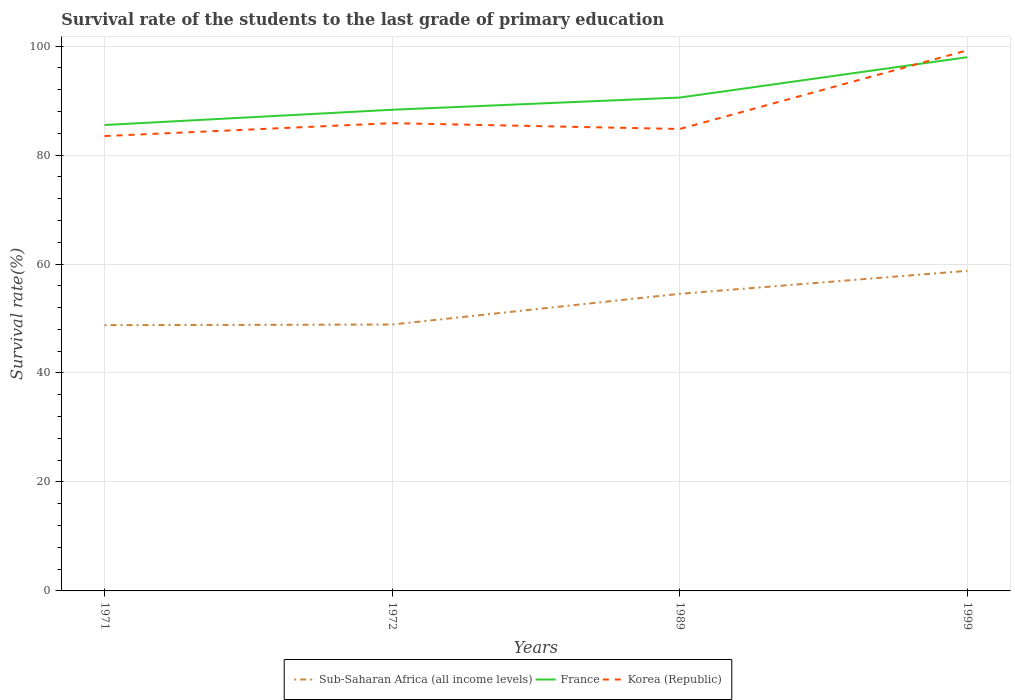How many different coloured lines are there?
Give a very brief answer. 3. Is the number of lines equal to the number of legend labels?
Offer a terse response. Yes. Across all years, what is the maximum survival rate of the students in Korea (Republic)?
Provide a succinct answer. 83.48. In which year was the survival rate of the students in France maximum?
Keep it short and to the point. 1971. What is the total survival rate of the students in Korea (Republic) in the graph?
Offer a very short reply. -15.73. What is the difference between the highest and the second highest survival rate of the students in Korea (Republic)?
Your answer should be very brief. 15.73. Is the survival rate of the students in France strictly greater than the survival rate of the students in Sub-Saharan Africa (all income levels) over the years?
Your answer should be compact. No. How many lines are there?
Your answer should be compact. 3. What is the difference between two consecutive major ticks on the Y-axis?
Give a very brief answer. 20. Are the values on the major ticks of Y-axis written in scientific E-notation?
Make the answer very short. No. Does the graph contain grids?
Offer a terse response. Yes. How many legend labels are there?
Ensure brevity in your answer.  3. How are the legend labels stacked?
Offer a terse response. Horizontal. What is the title of the graph?
Ensure brevity in your answer.  Survival rate of the students to the last grade of primary education. What is the label or title of the X-axis?
Offer a terse response. Years. What is the label or title of the Y-axis?
Your answer should be compact. Survival rate(%). What is the Survival rate(%) in Sub-Saharan Africa (all income levels) in 1971?
Offer a terse response. 48.78. What is the Survival rate(%) in France in 1971?
Make the answer very short. 85.51. What is the Survival rate(%) of Korea (Republic) in 1971?
Make the answer very short. 83.48. What is the Survival rate(%) of Sub-Saharan Africa (all income levels) in 1972?
Give a very brief answer. 48.89. What is the Survival rate(%) in France in 1972?
Make the answer very short. 88.31. What is the Survival rate(%) of Korea (Republic) in 1972?
Offer a terse response. 85.85. What is the Survival rate(%) of Sub-Saharan Africa (all income levels) in 1989?
Keep it short and to the point. 54.53. What is the Survival rate(%) of France in 1989?
Ensure brevity in your answer.  90.55. What is the Survival rate(%) of Korea (Republic) in 1989?
Offer a very short reply. 84.78. What is the Survival rate(%) of Sub-Saharan Africa (all income levels) in 1999?
Make the answer very short. 58.75. What is the Survival rate(%) in France in 1999?
Your response must be concise. 97.96. What is the Survival rate(%) of Korea (Republic) in 1999?
Your response must be concise. 99.22. Across all years, what is the maximum Survival rate(%) of Sub-Saharan Africa (all income levels)?
Offer a terse response. 58.75. Across all years, what is the maximum Survival rate(%) of France?
Make the answer very short. 97.96. Across all years, what is the maximum Survival rate(%) in Korea (Republic)?
Ensure brevity in your answer.  99.22. Across all years, what is the minimum Survival rate(%) of Sub-Saharan Africa (all income levels)?
Give a very brief answer. 48.78. Across all years, what is the minimum Survival rate(%) of France?
Offer a very short reply. 85.51. Across all years, what is the minimum Survival rate(%) of Korea (Republic)?
Ensure brevity in your answer.  83.48. What is the total Survival rate(%) in Sub-Saharan Africa (all income levels) in the graph?
Your answer should be very brief. 210.94. What is the total Survival rate(%) of France in the graph?
Keep it short and to the point. 362.33. What is the total Survival rate(%) in Korea (Republic) in the graph?
Your response must be concise. 353.33. What is the difference between the Survival rate(%) in Sub-Saharan Africa (all income levels) in 1971 and that in 1972?
Offer a very short reply. -0.11. What is the difference between the Survival rate(%) of France in 1971 and that in 1972?
Ensure brevity in your answer.  -2.8. What is the difference between the Survival rate(%) of Korea (Republic) in 1971 and that in 1972?
Offer a very short reply. -2.37. What is the difference between the Survival rate(%) of Sub-Saharan Africa (all income levels) in 1971 and that in 1989?
Your answer should be compact. -5.75. What is the difference between the Survival rate(%) in France in 1971 and that in 1989?
Provide a succinct answer. -5.04. What is the difference between the Survival rate(%) in Korea (Republic) in 1971 and that in 1989?
Make the answer very short. -1.29. What is the difference between the Survival rate(%) of Sub-Saharan Africa (all income levels) in 1971 and that in 1999?
Offer a very short reply. -9.97. What is the difference between the Survival rate(%) in France in 1971 and that in 1999?
Offer a terse response. -12.45. What is the difference between the Survival rate(%) in Korea (Republic) in 1971 and that in 1999?
Provide a succinct answer. -15.73. What is the difference between the Survival rate(%) of Sub-Saharan Africa (all income levels) in 1972 and that in 1989?
Offer a very short reply. -5.64. What is the difference between the Survival rate(%) in France in 1972 and that in 1989?
Ensure brevity in your answer.  -2.24. What is the difference between the Survival rate(%) in Korea (Republic) in 1972 and that in 1989?
Your response must be concise. 1.07. What is the difference between the Survival rate(%) of Sub-Saharan Africa (all income levels) in 1972 and that in 1999?
Make the answer very short. -9.86. What is the difference between the Survival rate(%) in France in 1972 and that in 1999?
Make the answer very short. -9.65. What is the difference between the Survival rate(%) in Korea (Republic) in 1972 and that in 1999?
Ensure brevity in your answer.  -13.37. What is the difference between the Survival rate(%) in Sub-Saharan Africa (all income levels) in 1989 and that in 1999?
Your response must be concise. -4.22. What is the difference between the Survival rate(%) of France in 1989 and that in 1999?
Offer a terse response. -7.41. What is the difference between the Survival rate(%) of Korea (Republic) in 1989 and that in 1999?
Offer a terse response. -14.44. What is the difference between the Survival rate(%) of Sub-Saharan Africa (all income levels) in 1971 and the Survival rate(%) of France in 1972?
Your response must be concise. -39.53. What is the difference between the Survival rate(%) in Sub-Saharan Africa (all income levels) in 1971 and the Survival rate(%) in Korea (Republic) in 1972?
Make the answer very short. -37.07. What is the difference between the Survival rate(%) of France in 1971 and the Survival rate(%) of Korea (Republic) in 1972?
Ensure brevity in your answer.  -0.34. What is the difference between the Survival rate(%) of Sub-Saharan Africa (all income levels) in 1971 and the Survival rate(%) of France in 1989?
Your response must be concise. -41.77. What is the difference between the Survival rate(%) of Sub-Saharan Africa (all income levels) in 1971 and the Survival rate(%) of Korea (Republic) in 1989?
Keep it short and to the point. -36. What is the difference between the Survival rate(%) of France in 1971 and the Survival rate(%) of Korea (Republic) in 1989?
Offer a terse response. 0.73. What is the difference between the Survival rate(%) in Sub-Saharan Africa (all income levels) in 1971 and the Survival rate(%) in France in 1999?
Ensure brevity in your answer.  -49.18. What is the difference between the Survival rate(%) in Sub-Saharan Africa (all income levels) in 1971 and the Survival rate(%) in Korea (Republic) in 1999?
Offer a terse response. -50.44. What is the difference between the Survival rate(%) of France in 1971 and the Survival rate(%) of Korea (Republic) in 1999?
Offer a very short reply. -13.71. What is the difference between the Survival rate(%) of Sub-Saharan Africa (all income levels) in 1972 and the Survival rate(%) of France in 1989?
Provide a succinct answer. -41.66. What is the difference between the Survival rate(%) in Sub-Saharan Africa (all income levels) in 1972 and the Survival rate(%) in Korea (Republic) in 1989?
Provide a short and direct response. -35.89. What is the difference between the Survival rate(%) in France in 1972 and the Survival rate(%) in Korea (Republic) in 1989?
Your answer should be very brief. 3.53. What is the difference between the Survival rate(%) of Sub-Saharan Africa (all income levels) in 1972 and the Survival rate(%) of France in 1999?
Ensure brevity in your answer.  -49.07. What is the difference between the Survival rate(%) in Sub-Saharan Africa (all income levels) in 1972 and the Survival rate(%) in Korea (Republic) in 1999?
Your response must be concise. -50.33. What is the difference between the Survival rate(%) in France in 1972 and the Survival rate(%) in Korea (Republic) in 1999?
Keep it short and to the point. -10.91. What is the difference between the Survival rate(%) in Sub-Saharan Africa (all income levels) in 1989 and the Survival rate(%) in France in 1999?
Offer a very short reply. -43.43. What is the difference between the Survival rate(%) in Sub-Saharan Africa (all income levels) in 1989 and the Survival rate(%) in Korea (Republic) in 1999?
Your answer should be compact. -44.69. What is the difference between the Survival rate(%) of France in 1989 and the Survival rate(%) of Korea (Republic) in 1999?
Make the answer very short. -8.67. What is the average Survival rate(%) of Sub-Saharan Africa (all income levels) per year?
Make the answer very short. 52.74. What is the average Survival rate(%) in France per year?
Offer a very short reply. 90.58. What is the average Survival rate(%) of Korea (Republic) per year?
Provide a short and direct response. 88.33. In the year 1971, what is the difference between the Survival rate(%) of Sub-Saharan Africa (all income levels) and Survival rate(%) of France?
Offer a terse response. -36.73. In the year 1971, what is the difference between the Survival rate(%) of Sub-Saharan Africa (all income levels) and Survival rate(%) of Korea (Republic)?
Make the answer very short. -34.71. In the year 1971, what is the difference between the Survival rate(%) in France and Survival rate(%) in Korea (Republic)?
Provide a short and direct response. 2.02. In the year 1972, what is the difference between the Survival rate(%) in Sub-Saharan Africa (all income levels) and Survival rate(%) in France?
Your answer should be very brief. -39.42. In the year 1972, what is the difference between the Survival rate(%) in Sub-Saharan Africa (all income levels) and Survival rate(%) in Korea (Republic)?
Keep it short and to the point. -36.96. In the year 1972, what is the difference between the Survival rate(%) in France and Survival rate(%) in Korea (Republic)?
Your response must be concise. 2.46. In the year 1989, what is the difference between the Survival rate(%) of Sub-Saharan Africa (all income levels) and Survival rate(%) of France?
Give a very brief answer. -36.02. In the year 1989, what is the difference between the Survival rate(%) in Sub-Saharan Africa (all income levels) and Survival rate(%) in Korea (Republic)?
Your answer should be compact. -30.25. In the year 1989, what is the difference between the Survival rate(%) in France and Survival rate(%) in Korea (Republic)?
Give a very brief answer. 5.77. In the year 1999, what is the difference between the Survival rate(%) in Sub-Saharan Africa (all income levels) and Survival rate(%) in France?
Give a very brief answer. -39.21. In the year 1999, what is the difference between the Survival rate(%) in Sub-Saharan Africa (all income levels) and Survival rate(%) in Korea (Republic)?
Keep it short and to the point. -40.47. In the year 1999, what is the difference between the Survival rate(%) of France and Survival rate(%) of Korea (Republic)?
Make the answer very short. -1.26. What is the ratio of the Survival rate(%) of Sub-Saharan Africa (all income levels) in 1971 to that in 1972?
Your answer should be very brief. 1. What is the ratio of the Survival rate(%) in France in 1971 to that in 1972?
Your response must be concise. 0.97. What is the ratio of the Survival rate(%) of Korea (Republic) in 1971 to that in 1972?
Your response must be concise. 0.97. What is the ratio of the Survival rate(%) in Sub-Saharan Africa (all income levels) in 1971 to that in 1989?
Your answer should be compact. 0.89. What is the ratio of the Survival rate(%) in France in 1971 to that in 1989?
Provide a succinct answer. 0.94. What is the ratio of the Survival rate(%) of Korea (Republic) in 1971 to that in 1989?
Give a very brief answer. 0.98. What is the ratio of the Survival rate(%) in Sub-Saharan Africa (all income levels) in 1971 to that in 1999?
Offer a terse response. 0.83. What is the ratio of the Survival rate(%) in France in 1971 to that in 1999?
Keep it short and to the point. 0.87. What is the ratio of the Survival rate(%) of Korea (Republic) in 1971 to that in 1999?
Provide a short and direct response. 0.84. What is the ratio of the Survival rate(%) of Sub-Saharan Africa (all income levels) in 1972 to that in 1989?
Make the answer very short. 0.9. What is the ratio of the Survival rate(%) of France in 1972 to that in 1989?
Ensure brevity in your answer.  0.98. What is the ratio of the Survival rate(%) in Korea (Republic) in 1972 to that in 1989?
Provide a short and direct response. 1.01. What is the ratio of the Survival rate(%) in Sub-Saharan Africa (all income levels) in 1972 to that in 1999?
Offer a terse response. 0.83. What is the ratio of the Survival rate(%) of France in 1972 to that in 1999?
Make the answer very short. 0.9. What is the ratio of the Survival rate(%) in Korea (Republic) in 1972 to that in 1999?
Your response must be concise. 0.87. What is the ratio of the Survival rate(%) in Sub-Saharan Africa (all income levels) in 1989 to that in 1999?
Your answer should be compact. 0.93. What is the ratio of the Survival rate(%) in France in 1989 to that in 1999?
Keep it short and to the point. 0.92. What is the ratio of the Survival rate(%) of Korea (Republic) in 1989 to that in 1999?
Give a very brief answer. 0.85. What is the difference between the highest and the second highest Survival rate(%) of Sub-Saharan Africa (all income levels)?
Your response must be concise. 4.22. What is the difference between the highest and the second highest Survival rate(%) of France?
Provide a succinct answer. 7.41. What is the difference between the highest and the second highest Survival rate(%) of Korea (Republic)?
Provide a short and direct response. 13.37. What is the difference between the highest and the lowest Survival rate(%) in Sub-Saharan Africa (all income levels)?
Keep it short and to the point. 9.97. What is the difference between the highest and the lowest Survival rate(%) in France?
Provide a short and direct response. 12.45. What is the difference between the highest and the lowest Survival rate(%) of Korea (Republic)?
Keep it short and to the point. 15.73. 